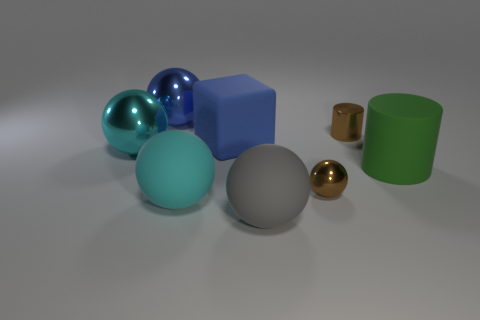Can you describe the lighting and shadows in the scene? The lighting in the scene is soft and diffuse, coming from above and casting gentle shadows below each object. The even spread of light accentuates the objects' shapes and materials without creating harsh highlights or overly dark shadows. This type of lighting helps to maintain the visibility of the objects' textures and colors. 